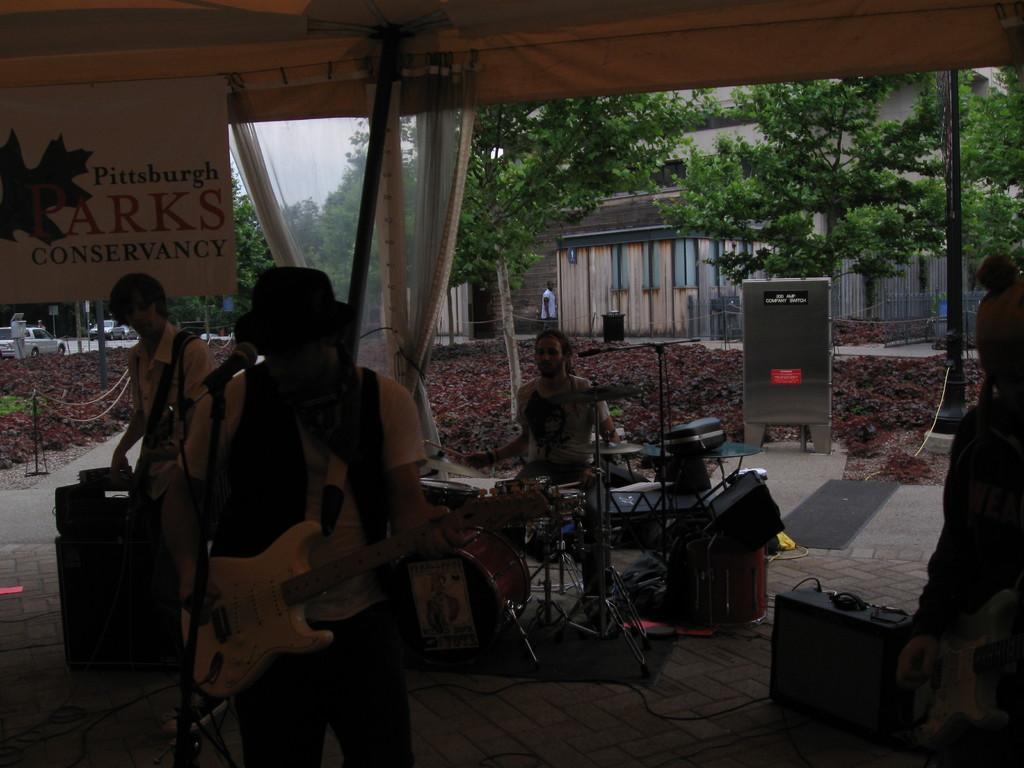How would you summarize this image in a sentence or two? In the image we can see there are men who are standing and holding guitar in their hands and at the back there is a man who is sitting and playing drums and at the back there are lot of trees. 